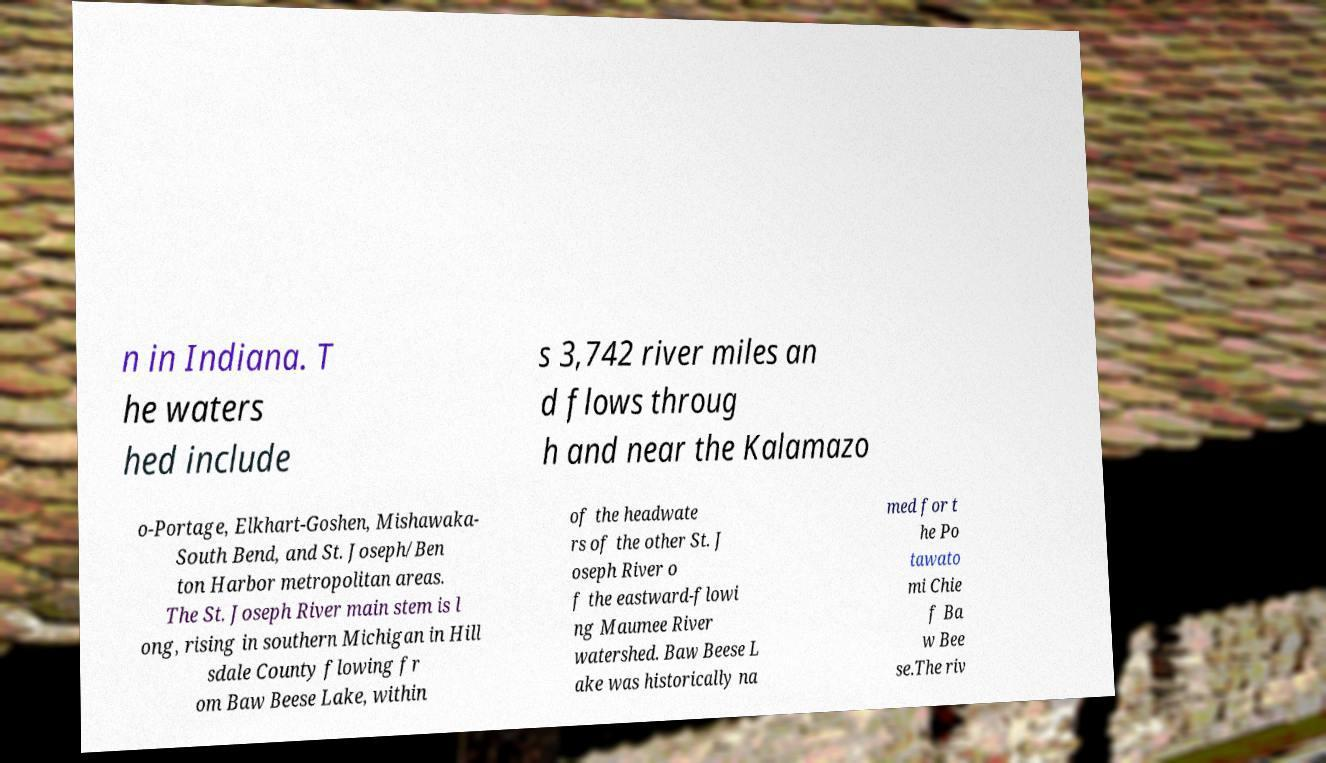Please identify and transcribe the text found in this image. n in Indiana. T he waters hed include s 3,742 river miles an d flows throug h and near the Kalamazo o-Portage, Elkhart-Goshen, Mishawaka- South Bend, and St. Joseph/Ben ton Harbor metropolitan areas. The St. Joseph River main stem is l ong, rising in southern Michigan in Hill sdale County flowing fr om Baw Beese Lake, within of the headwate rs of the other St. J oseph River o f the eastward-flowi ng Maumee River watershed. Baw Beese L ake was historically na med for t he Po tawato mi Chie f Ba w Bee se.The riv 